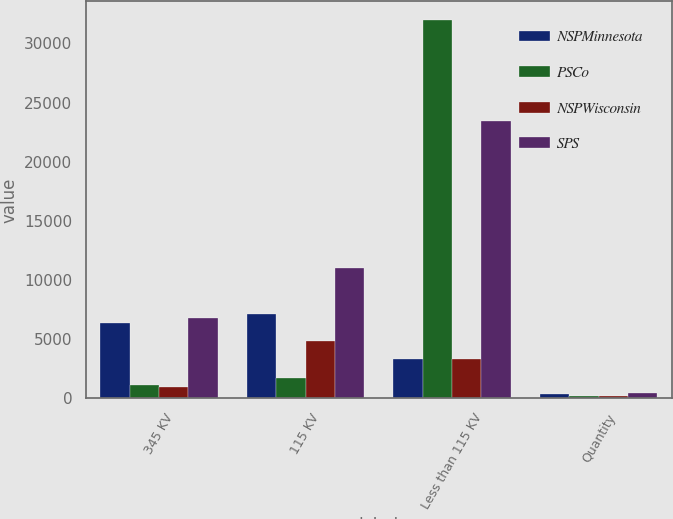Convert chart. <chart><loc_0><loc_0><loc_500><loc_500><stacked_bar_chart><ecel><fcel>345 KV<fcel>115 KV<fcel>Less than 115 KV<fcel>Quantity<nl><fcel>NSPMinnesota<fcel>6385<fcel>7103<fcel>3301.5<fcel>375<nl><fcel>PSCo<fcel>1152<fcel>1761<fcel>31956<fcel>203<nl><fcel>NSPWisconsin<fcel>959<fcel>4842<fcel>3301.5<fcel>221<nl><fcel>SPS<fcel>6800<fcel>11034<fcel>23403<fcel>437<nl></chart> 